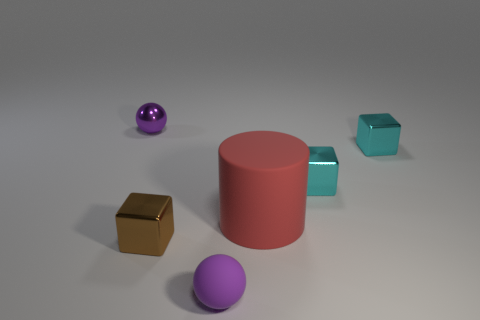Subtract all cyan cubes. How many cubes are left? 1 Subtract all cylinders. How many objects are left? 5 Add 1 small purple cylinders. How many objects exist? 7 Subtract all cyan cubes. How many cubes are left? 1 Add 2 matte things. How many matte things are left? 4 Add 4 red cubes. How many red cubes exist? 4 Subtract 0 cyan cylinders. How many objects are left? 6 Subtract 2 cubes. How many cubes are left? 1 Subtract all purple cubes. Subtract all green cylinders. How many cubes are left? 3 Subtract all green cylinders. How many cyan blocks are left? 2 